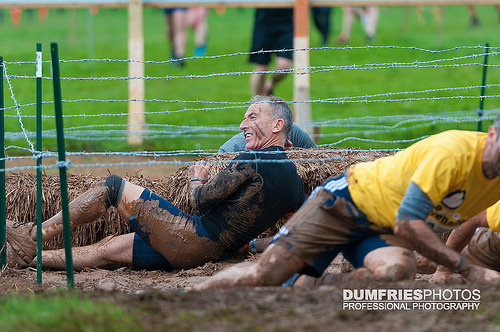<image>
Is there a man above the mud? No. The man is not positioned above the mud. The vertical arrangement shows a different relationship. 